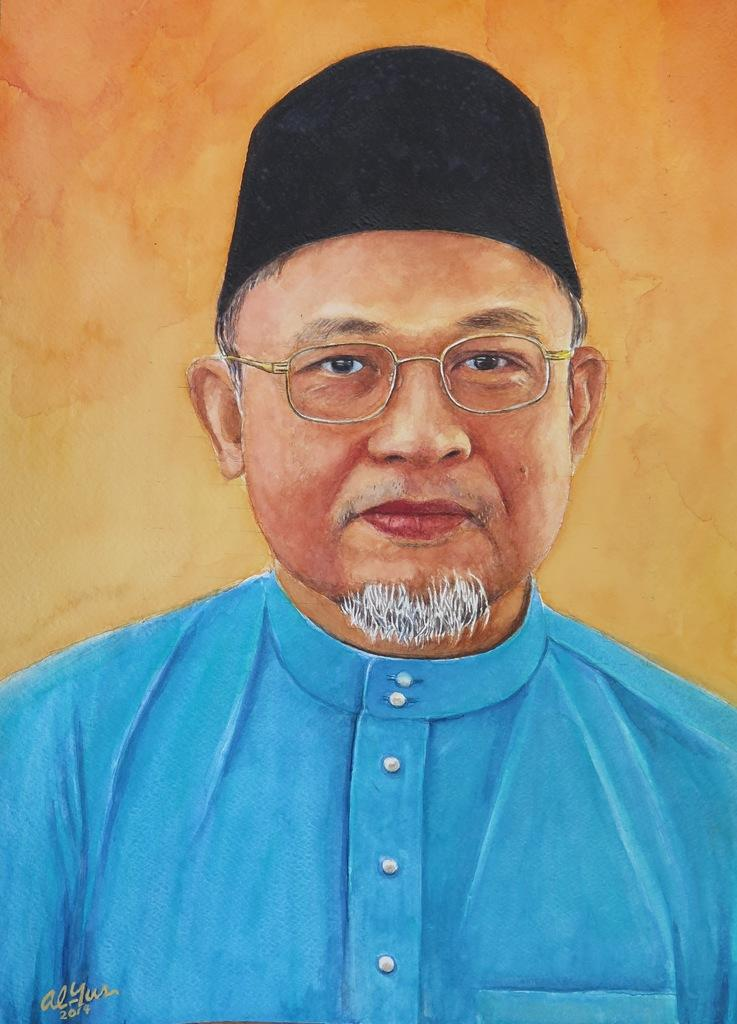What is the main subject of the painting in the image? The main subject of the painting in the image is a person. Is there any text associated with the painting? Yes, there is some text at the bottom of the image. What type of liquid is being poured by the goose in the image? There is no goose or liquid present in the image; it features a painting of a person with text at the bottom. 